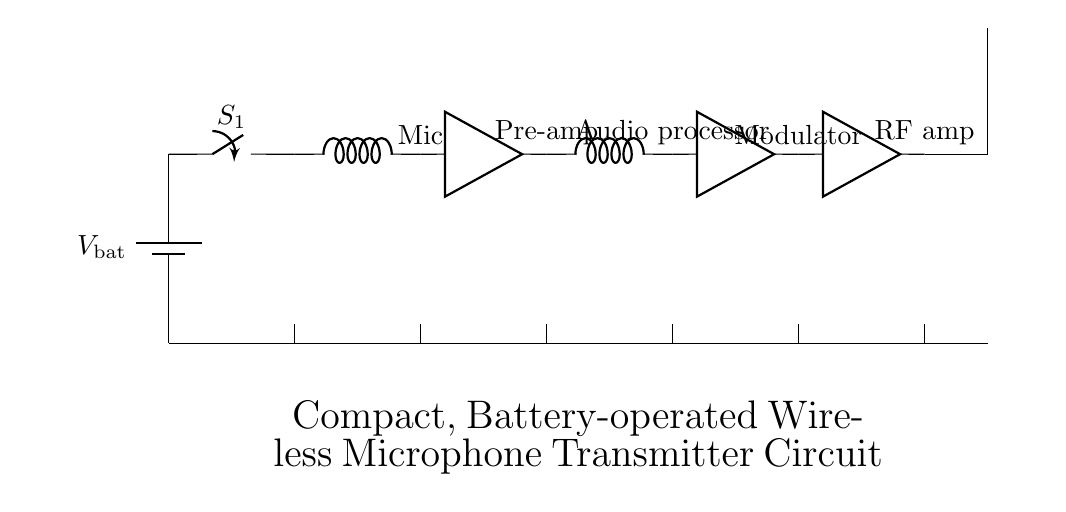What is the main power source of the circuit? The main power source is the battery, indicated at the base of the circuit diagram, which supplies power to all components.
Answer: battery What component is responsible for amplifying the audio signal? The pre-amplifier is the component that amplifies the audio signal, as seen directly after the microphone in the circuit.
Answer: Pre-amp Which components in the circuit are amplifiers? The circuit has three amplifiers: the pre-amplifier, the modulator, and the RF amplifier. This can be determined by identifying the labels next to the relevant components in the circuit diagram.
Answer: Pre-amp, Modulator, RF amp What type of antenna is used in this circuit? The circuit uses a standard antenna, as denoted in the diagram. The presence of the symbol specifically indicates the antenna's function in the circuit.
Answer: Antenna Why is battery operation important for this microphone transmitter? Battery operation is crucial as it enhances portability, allowing the microphone to be used wirelessly in various environments without requiring a power outlet. The entire circuit is designed for low power consumption to ensure prolonged usage.
Answer: Portability How many audio processing stages are there in the circuit? There are two audio processing stages, which include the pre-amplifier and the audio processor. These stages are connected in sequence, as seen in the circuit layout.
Answer: 2 What happens when the power switch is turned on? When the power switch is closed, it completes the circuit, allowing current from the battery to flow through all components, thereby powering the entire system for operation.
Answer: Current flows 